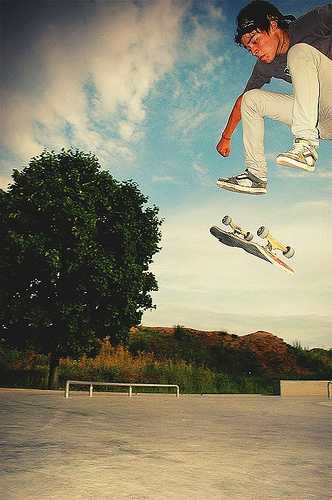Describe the objects in this image and their specific colors. I can see people in black, tan, and beige tones and skateboard in black, khaki, beige, and gray tones in this image. 